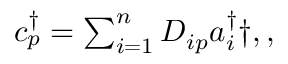<formula> <loc_0><loc_0><loc_500><loc_500>\begin{array} { r } { c _ { p } ^ { \dagger } = \sum _ { i = 1 } ^ { n } D _ { i p } a _ { i } ^ { \dagger } \dag , , } \end{array}</formula> 